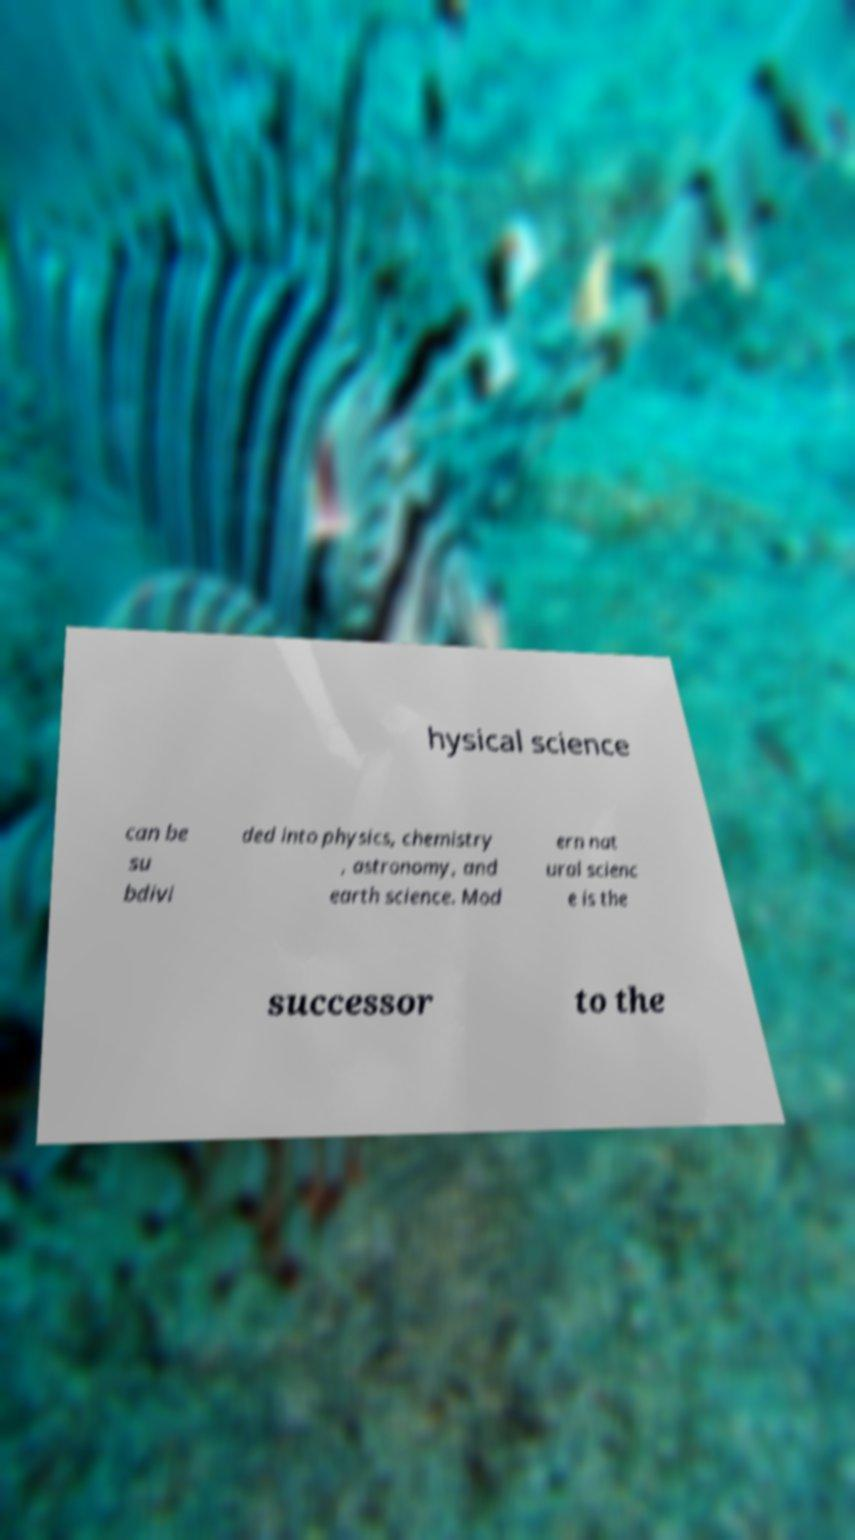What messages or text are displayed in this image? I need them in a readable, typed format. hysical science can be su bdivi ded into physics, chemistry , astronomy, and earth science. Mod ern nat ural scienc e is the successor to the 